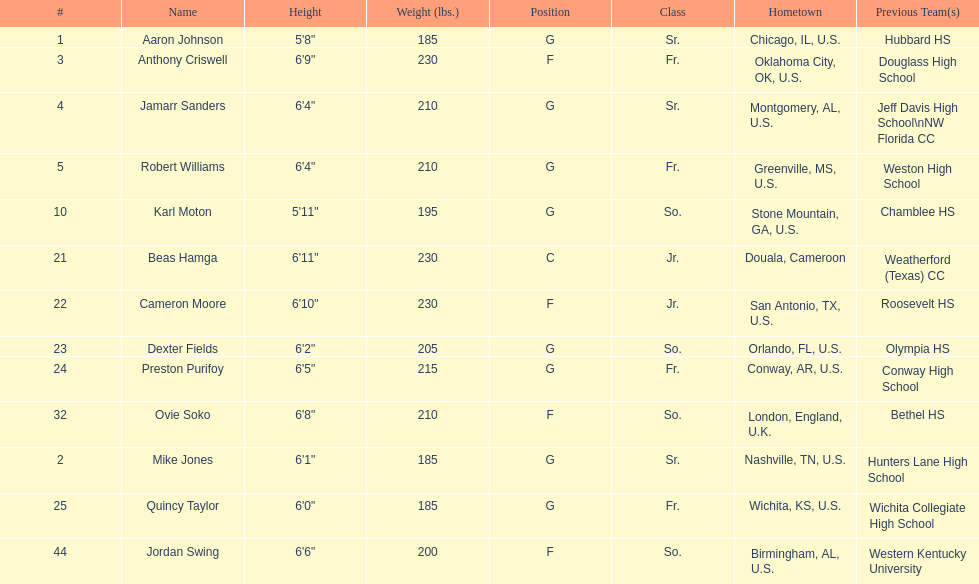Other than soko, tell me a player who is not from the us. Beas Hamga. 